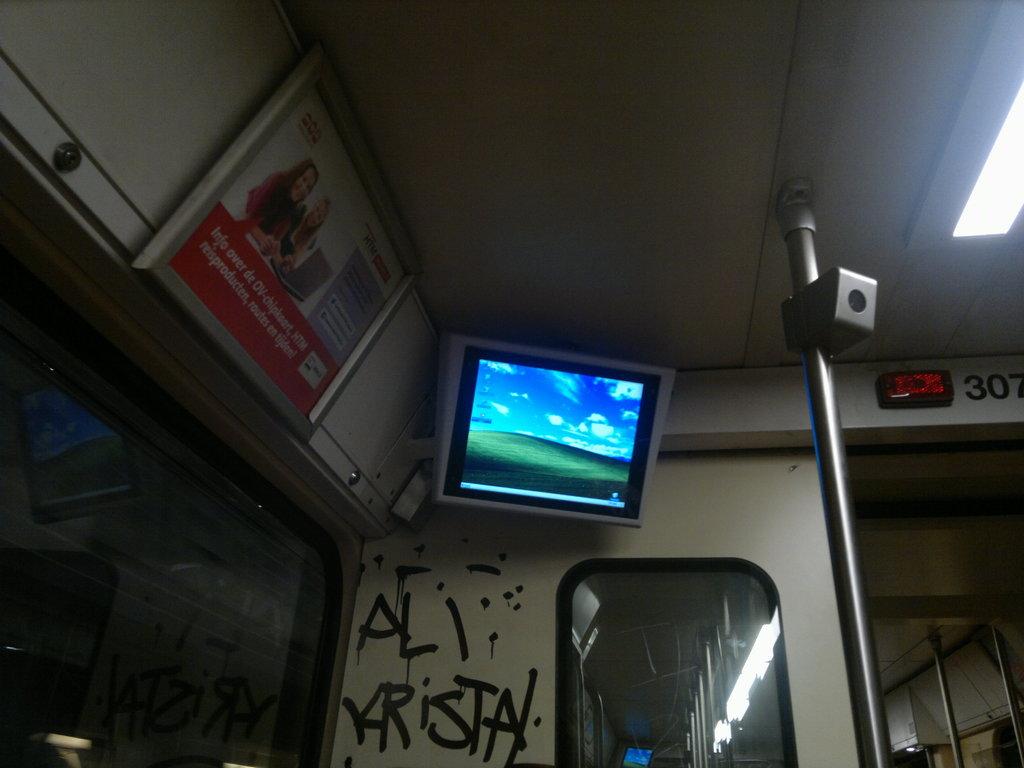What is written on the wall?
Your answer should be very brief. Ali krista. What are the 3 numbers on the top right?
Make the answer very short. 307. 